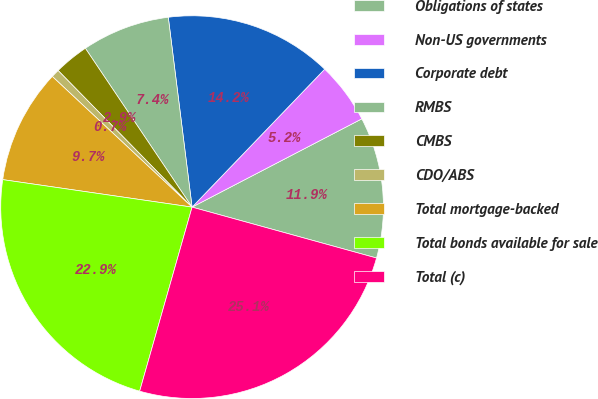<chart> <loc_0><loc_0><loc_500><loc_500><pie_chart><fcel>Obligations of states<fcel>Non-US governments<fcel>Corporate debt<fcel>RMBS<fcel>CMBS<fcel>CDO/ABS<fcel>Total mortgage-backed<fcel>Total bonds available for sale<fcel>Total (c)<nl><fcel>11.92%<fcel>5.18%<fcel>14.17%<fcel>7.43%<fcel>2.93%<fcel>0.69%<fcel>9.67%<fcel>22.88%<fcel>25.13%<nl></chart> 